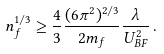<formula> <loc_0><loc_0><loc_500><loc_500>n _ { f } ^ { 1 / 3 } \geq \frac { 4 } { 3 } \frac { ( 6 \pi ^ { 2 } ) ^ { 2 / 3 } } { 2 m _ { f } } \frac { \lambda } { U _ { B F } ^ { 2 } } \, .</formula> 